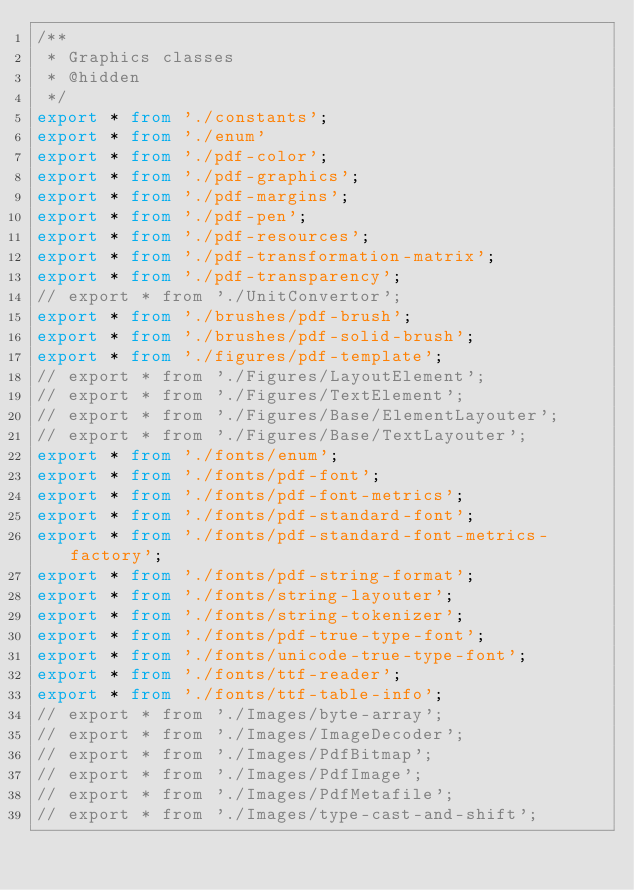<code> <loc_0><loc_0><loc_500><loc_500><_TypeScript_>/**
 * Graphics classes
 * @hidden
 */
export * from './constants';
export * from './enum'
export * from './pdf-color';
export * from './pdf-graphics';
export * from './pdf-margins';
export * from './pdf-pen';
export * from './pdf-resources';
export * from './pdf-transformation-matrix';
export * from './pdf-transparency';
// export * from './UnitConvertor';
export * from './brushes/pdf-brush';
export * from './brushes/pdf-solid-brush';
export * from './figures/pdf-template';
// export * from './Figures/LayoutElement';
// export * from './Figures/TextElement';
// export * from './Figures/Base/ElementLayouter';
// export * from './Figures/Base/TextLayouter';
export * from './fonts/enum';
export * from './fonts/pdf-font';
export * from './fonts/pdf-font-metrics';
export * from './fonts/pdf-standard-font';
export * from './fonts/pdf-standard-font-metrics-factory';
export * from './fonts/pdf-string-format';
export * from './fonts/string-layouter';
export * from './fonts/string-tokenizer';
export * from './fonts/pdf-true-type-font';
export * from './fonts/unicode-true-type-font';
export * from './fonts/ttf-reader';
export * from './fonts/ttf-table-info';
// export * from './Images/byte-array';
// export * from './Images/ImageDecoder';
// export * from './Images/PdfBitmap';
// export * from './Images/PdfImage';
// export * from './Images/PdfMetafile';
// export * from './Images/type-cast-and-shift';</code> 